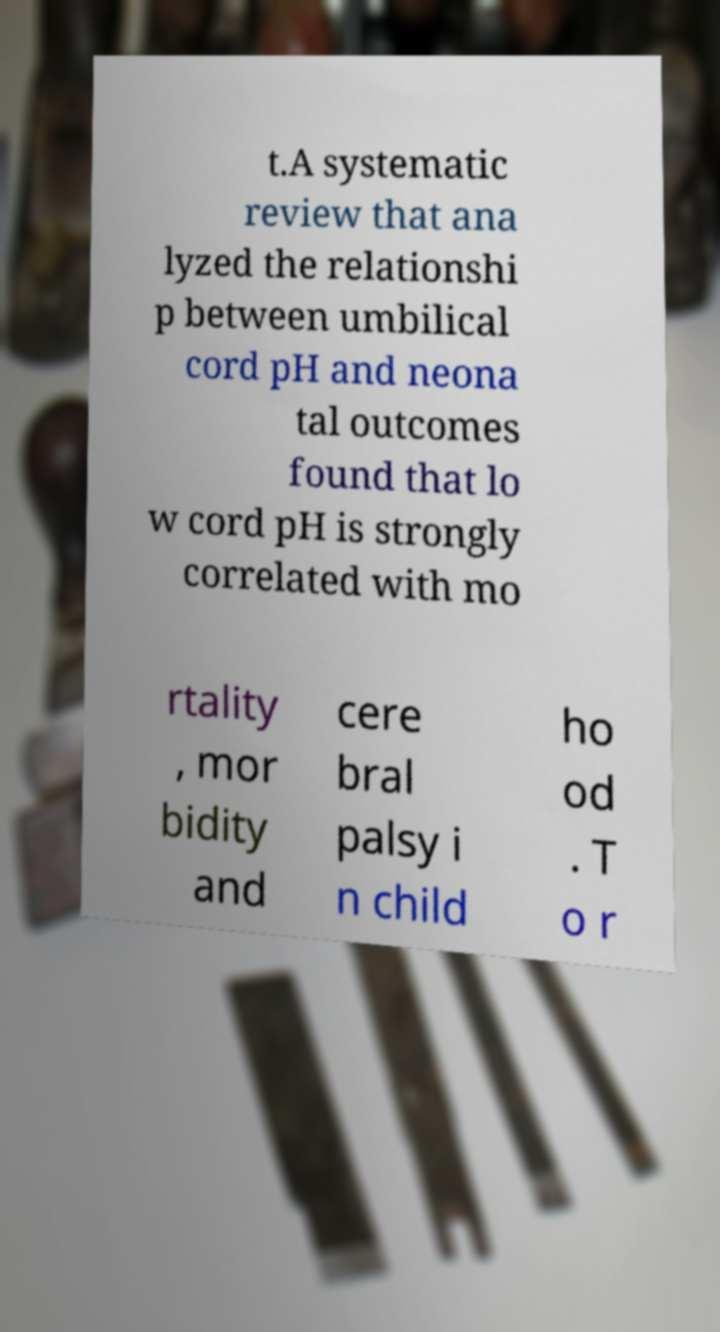I need the written content from this picture converted into text. Can you do that? t.A systematic review that ana lyzed the relationshi p between umbilical cord pH and neona tal outcomes found that lo w cord pH is strongly correlated with mo rtality , mor bidity and cere bral palsy i n child ho od . T o r 